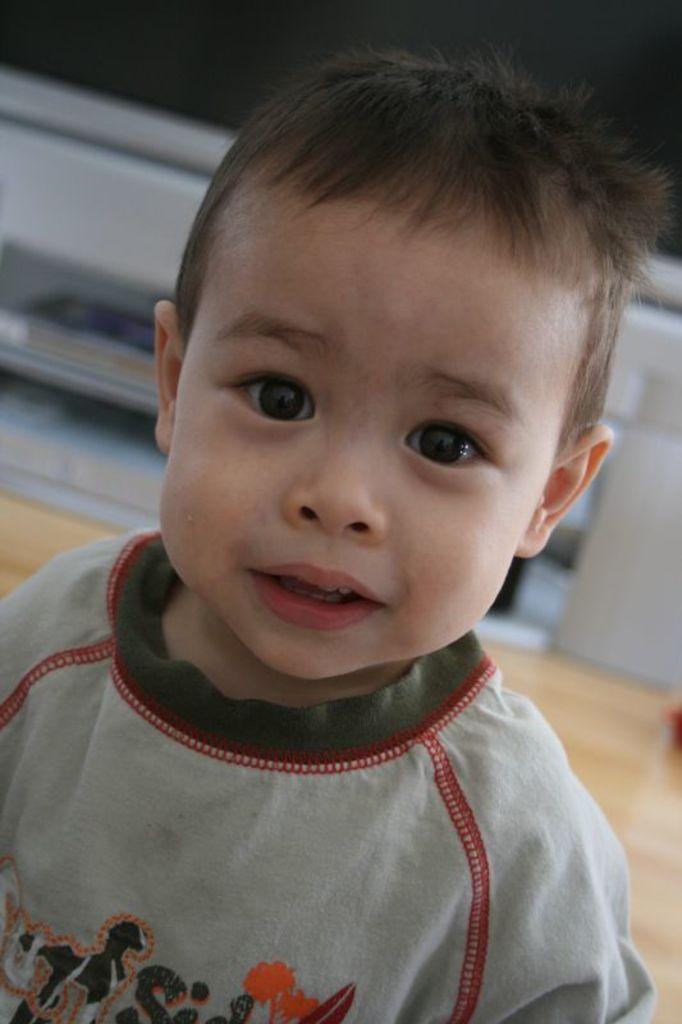Please provide a concise description of this image. In this image I can see a boy in the front and I can see he is wearing grey colour t shirt. 